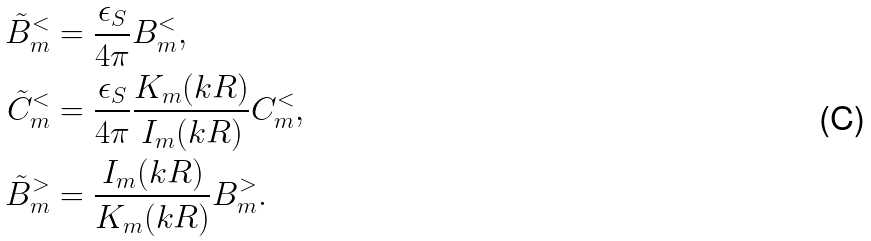<formula> <loc_0><loc_0><loc_500><loc_500>\tilde { B } _ { m } ^ { < } & = \frac { \epsilon _ { S } } { 4 \pi } B _ { m } ^ { < } , \\ \tilde { C } _ { m } ^ { < } & = \frac { \epsilon _ { S } } { 4 \pi } \frac { K _ { m } ( k R ) } { I _ { m } ( k R ) } C _ { m } ^ { < } , \\ \tilde { B } _ { m } ^ { > } & = \frac { I _ { m } ( k R ) } { K _ { m } ( k R ) } B _ { m } ^ { > } .</formula> 